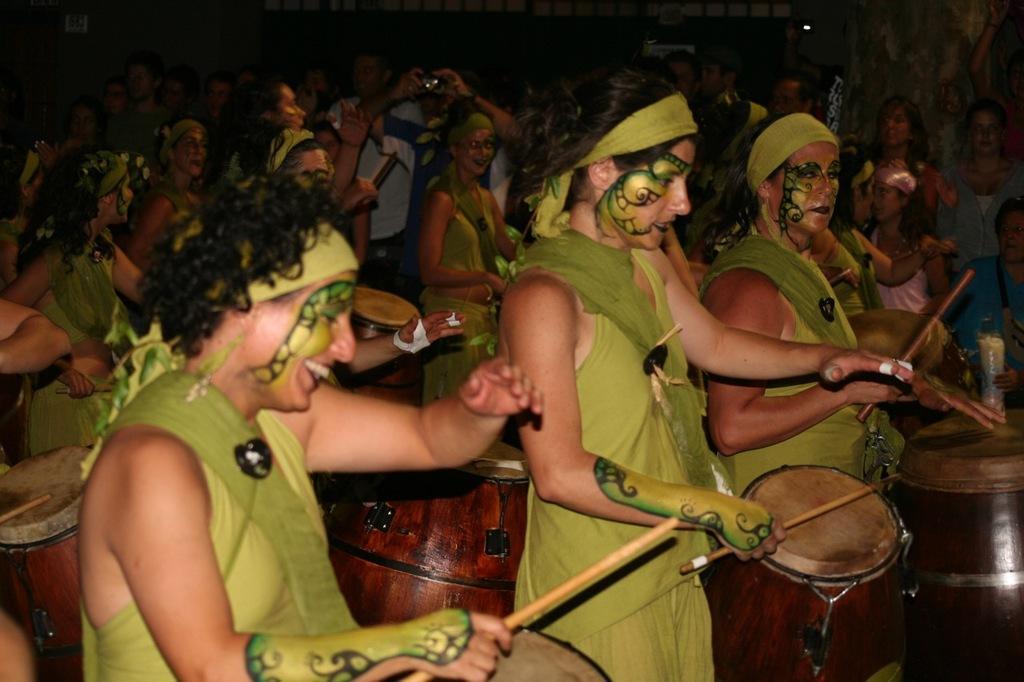How would you summarize this image in a sentence or two? In this few group of people are playing drums with the help of stick and few group of people are standing and seeing. A person in middle of image who is behind a girl is taking picture with the help of camera. 